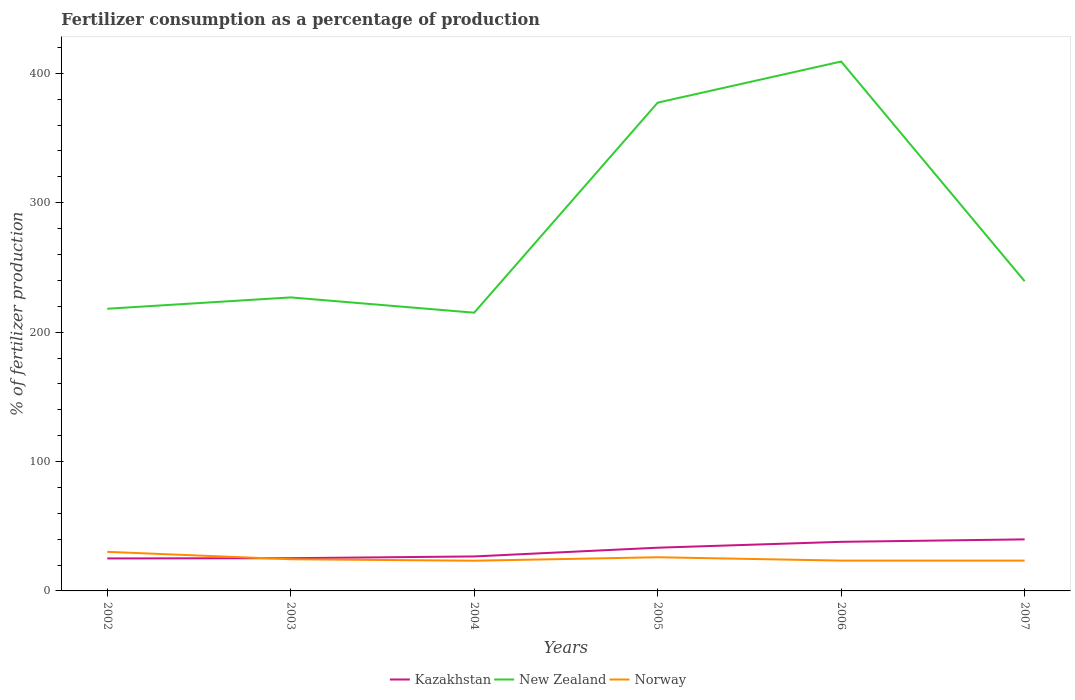Does the line corresponding to Norway intersect with the line corresponding to Kazakhstan?
Give a very brief answer. Yes. Is the number of lines equal to the number of legend labels?
Provide a short and direct response. Yes. Across all years, what is the maximum percentage of fertilizers consumed in New Zealand?
Make the answer very short. 215.02. What is the total percentage of fertilizers consumed in Norway in the graph?
Make the answer very short. 6.76. What is the difference between the highest and the second highest percentage of fertilizers consumed in Norway?
Give a very brief answer. 6.85. What is the difference between the highest and the lowest percentage of fertilizers consumed in New Zealand?
Ensure brevity in your answer.  2. How many lines are there?
Your answer should be very brief. 3. Are the values on the major ticks of Y-axis written in scientific E-notation?
Your answer should be compact. No. How are the legend labels stacked?
Your answer should be very brief. Horizontal. What is the title of the graph?
Give a very brief answer. Fertilizer consumption as a percentage of production. What is the label or title of the X-axis?
Provide a short and direct response. Years. What is the label or title of the Y-axis?
Keep it short and to the point. % of fertilizer production. What is the % of fertilizer production in Kazakhstan in 2002?
Offer a very short reply. 25.11. What is the % of fertilizer production of New Zealand in 2002?
Give a very brief answer. 218.08. What is the % of fertilizer production in Norway in 2002?
Keep it short and to the point. 30.19. What is the % of fertilizer production in Kazakhstan in 2003?
Your response must be concise. 25.3. What is the % of fertilizer production in New Zealand in 2003?
Provide a short and direct response. 226.83. What is the % of fertilizer production of Norway in 2003?
Make the answer very short. 24.48. What is the % of fertilizer production in Kazakhstan in 2004?
Your response must be concise. 26.65. What is the % of fertilizer production of New Zealand in 2004?
Offer a very short reply. 215.02. What is the % of fertilizer production in Norway in 2004?
Make the answer very short. 23.34. What is the % of fertilizer production of Kazakhstan in 2005?
Make the answer very short. 33.4. What is the % of fertilizer production in New Zealand in 2005?
Offer a terse response. 377.35. What is the % of fertilizer production in Norway in 2005?
Keep it short and to the point. 26.02. What is the % of fertilizer production in Kazakhstan in 2006?
Provide a short and direct response. 37.94. What is the % of fertilizer production in New Zealand in 2006?
Keep it short and to the point. 409.12. What is the % of fertilizer production in Norway in 2006?
Make the answer very short. 23.43. What is the % of fertilizer production in Kazakhstan in 2007?
Provide a succinct answer. 39.84. What is the % of fertilizer production of New Zealand in 2007?
Keep it short and to the point. 239.35. What is the % of fertilizer production of Norway in 2007?
Make the answer very short. 23.42. Across all years, what is the maximum % of fertilizer production in Kazakhstan?
Provide a short and direct response. 39.84. Across all years, what is the maximum % of fertilizer production of New Zealand?
Provide a short and direct response. 409.12. Across all years, what is the maximum % of fertilizer production in Norway?
Offer a very short reply. 30.19. Across all years, what is the minimum % of fertilizer production of Kazakhstan?
Make the answer very short. 25.11. Across all years, what is the minimum % of fertilizer production of New Zealand?
Provide a short and direct response. 215.02. Across all years, what is the minimum % of fertilizer production of Norway?
Offer a terse response. 23.34. What is the total % of fertilizer production of Kazakhstan in the graph?
Give a very brief answer. 188.23. What is the total % of fertilizer production in New Zealand in the graph?
Your answer should be very brief. 1685.75. What is the total % of fertilizer production of Norway in the graph?
Make the answer very short. 150.89. What is the difference between the % of fertilizer production of Kazakhstan in 2002 and that in 2003?
Your answer should be very brief. -0.19. What is the difference between the % of fertilizer production in New Zealand in 2002 and that in 2003?
Provide a succinct answer. -8.76. What is the difference between the % of fertilizer production of Norway in 2002 and that in 2003?
Offer a terse response. 5.71. What is the difference between the % of fertilizer production in Kazakhstan in 2002 and that in 2004?
Provide a succinct answer. -1.54. What is the difference between the % of fertilizer production in New Zealand in 2002 and that in 2004?
Ensure brevity in your answer.  3.05. What is the difference between the % of fertilizer production in Norway in 2002 and that in 2004?
Offer a very short reply. 6.85. What is the difference between the % of fertilizer production of Kazakhstan in 2002 and that in 2005?
Give a very brief answer. -8.3. What is the difference between the % of fertilizer production of New Zealand in 2002 and that in 2005?
Offer a terse response. -159.28. What is the difference between the % of fertilizer production of Norway in 2002 and that in 2005?
Offer a terse response. 4.18. What is the difference between the % of fertilizer production of Kazakhstan in 2002 and that in 2006?
Your answer should be compact. -12.83. What is the difference between the % of fertilizer production of New Zealand in 2002 and that in 2006?
Offer a terse response. -191.04. What is the difference between the % of fertilizer production in Norway in 2002 and that in 2006?
Ensure brevity in your answer.  6.76. What is the difference between the % of fertilizer production of Kazakhstan in 2002 and that in 2007?
Ensure brevity in your answer.  -14.73. What is the difference between the % of fertilizer production in New Zealand in 2002 and that in 2007?
Make the answer very short. -21.27. What is the difference between the % of fertilizer production of Norway in 2002 and that in 2007?
Your response must be concise. 6.77. What is the difference between the % of fertilizer production in Kazakhstan in 2003 and that in 2004?
Your response must be concise. -1.35. What is the difference between the % of fertilizer production in New Zealand in 2003 and that in 2004?
Your response must be concise. 11.81. What is the difference between the % of fertilizer production in Norway in 2003 and that in 2004?
Your answer should be very brief. 1.14. What is the difference between the % of fertilizer production of Kazakhstan in 2003 and that in 2005?
Offer a very short reply. -8.1. What is the difference between the % of fertilizer production of New Zealand in 2003 and that in 2005?
Provide a short and direct response. -150.52. What is the difference between the % of fertilizer production in Norway in 2003 and that in 2005?
Your answer should be compact. -1.53. What is the difference between the % of fertilizer production of Kazakhstan in 2003 and that in 2006?
Your answer should be compact. -12.64. What is the difference between the % of fertilizer production of New Zealand in 2003 and that in 2006?
Offer a very short reply. -182.28. What is the difference between the % of fertilizer production in Norway in 2003 and that in 2006?
Keep it short and to the point. 1.05. What is the difference between the % of fertilizer production of Kazakhstan in 2003 and that in 2007?
Offer a terse response. -14.54. What is the difference between the % of fertilizer production in New Zealand in 2003 and that in 2007?
Your response must be concise. -12.51. What is the difference between the % of fertilizer production of Norway in 2003 and that in 2007?
Ensure brevity in your answer.  1.06. What is the difference between the % of fertilizer production of Kazakhstan in 2004 and that in 2005?
Offer a terse response. -6.76. What is the difference between the % of fertilizer production of New Zealand in 2004 and that in 2005?
Your response must be concise. -162.33. What is the difference between the % of fertilizer production of Norway in 2004 and that in 2005?
Give a very brief answer. -2.67. What is the difference between the % of fertilizer production in Kazakhstan in 2004 and that in 2006?
Keep it short and to the point. -11.29. What is the difference between the % of fertilizer production of New Zealand in 2004 and that in 2006?
Provide a succinct answer. -194.1. What is the difference between the % of fertilizer production in Norway in 2004 and that in 2006?
Offer a very short reply. -0.09. What is the difference between the % of fertilizer production in Kazakhstan in 2004 and that in 2007?
Your answer should be very brief. -13.19. What is the difference between the % of fertilizer production of New Zealand in 2004 and that in 2007?
Provide a succinct answer. -24.33. What is the difference between the % of fertilizer production of Norway in 2004 and that in 2007?
Provide a short and direct response. -0.08. What is the difference between the % of fertilizer production in Kazakhstan in 2005 and that in 2006?
Offer a very short reply. -4.54. What is the difference between the % of fertilizer production of New Zealand in 2005 and that in 2006?
Your response must be concise. -31.76. What is the difference between the % of fertilizer production of Norway in 2005 and that in 2006?
Your response must be concise. 2.58. What is the difference between the % of fertilizer production of Kazakhstan in 2005 and that in 2007?
Provide a short and direct response. -6.44. What is the difference between the % of fertilizer production of New Zealand in 2005 and that in 2007?
Provide a succinct answer. 138.01. What is the difference between the % of fertilizer production of Norway in 2005 and that in 2007?
Offer a terse response. 2.6. What is the difference between the % of fertilizer production of Kazakhstan in 2006 and that in 2007?
Your answer should be very brief. -1.9. What is the difference between the % of fertilizer production in New Zealand in 2006 and that in 2007?
Provide a short and direct response. 169.77. What is the difference between the % of fertilizer production in Norway in 2006 and that in 2007?
Your answer should be very brief. 0.01. What is the difference between the % of fertilizer production in Kazakhstan in 2002 and the % of fertilizer production in New Zealand in 2003?
Give a very brief answer. -201.73. What is the difference between the % of fertilizer production in Kazakhstan in 2002 and the % of fertilizer production in Norway in 2003?
Your answer should be very brief. 0.62. What is the difference between the % of fertilizer production of New Zealand in 2002 and the % of fertilizer production of Norway in 2003?
Your answer should be very brief. 193.59. What is the difference between the % of fertilizer production of Kazakhstan in 2002 and the % of fertilizer production of New Zealand in 2004?
Provide a short and direct response. -189.91. What is the difference between the % of fertilizer production of Kazakhstan in 2002 and the % of fertilizer production of Norway in 2004?
Provide a short and direct response. 1.76. What is the difference between the % of fertilizer production in New Zealand in 2002 and the % of fertilizer production in Norway in 2004?
Give a very brief answer. 194.73. What is the difference between the % of fertilizer production of Kazakhstan in 2002 and the % of fertilizer production of New Zealand in 2005?
Your response must be concise. -352.25. What is the difference between the % of fertilizer production of Kazakhstan in 2002 and the % of fertilizer production of Norway in 2005?
Offer a very short reply. -0.91. What is the difference between the % of fertilizer production in New Zealand in 2002 and the % of fertilizer production in Norway in 2005?
Your answer should be compact. 192.06. What is the difference between the % of fertilizer production in Kazakhstan in 2002 and the % of fertilizer production in New Zealand in 2006?
Provide a short and direct response. -384.01. What is the difference between the % of fertilizer production in Kazakhstan in 2002 and the % of fertilizer production in Norway in 2006?
Keep it short and to the point. 1.67. What is the difference between the % of fertilizer production in New Zealand in 2002 and the % of fertilizer production in Norway in 2006?
Your answer should be compact. 194.64. What is the difference between the % of fertilizer production of Kazakhstan in 2002 and the % of fertilizer production of New Zealand in 2007?
Offer a very short reply. -214.24. What is the difference between the % of fertilizer production of Kazakhstan in 2002 and the % of fertilizer production of Norway in 2007?
Give a very brief answer. 1.69. What is the difference between the % of fertilizer production of New Zealand in 2002 and the % of fertilizer production of Norway in 2007?
Your answer should be very brief. 194.66. What is the difference between the % of fertilizer production in Kazakhstan in 2003 and the % of fertilizer production in New Zealand in 2004?
Offer a very short reply. -189.72. What is the difference between the % of fertilizer production of Kazakhstan in 2003 and the % of fertilizer production of Norway in 2004?
Make the answer very short. 1.95. What is the difference between the % of fertilizer production in New Zealand in 2003 and the % of fertilizer production in Norway in 2004?
Offer a very short reply. 203.49. What is the difference between the % of fertilizer production in Kazakhstan in 2003 and the % of fertilizer production in New Zealand in 2005?
Provide a succinct answer. -352.06. What is the difference between the % of fertilizer production in Kazakhstan in 2003 and the % of fertilizer production in Norway in 2005?
Offer a terse response. -0.72. What is the difference between the % of fertilizer production in New Zealand in 2003 and the % of fertilizer production in Norway in 2005?
Your answer should be compact. 200.82. What is the difference between the % of fertilizer production in Kazakhstan in 2003 and the % of fertilizer production in New Zealand in 2006?
Your response must be concise. -383.82. What is the difference between the % of fertilizer production of Kazakhstan in 2003 and the % of fertilizer production of Norway in 2006?
Your answer should be compact. 1.87. What is the difference between the % of fertilizer production of New Zealand in 2003 and the % of fertilizer production of Norway in 2006?
Provide a succinct answer. 203.4. What is the difference between the % of fertilizer production of Kazakhstan in 2003 and the % of fertilizer production of New Zealand in 2007?
Make the answer very short. -214.05. What is the difference between the % of fertilizer production of Kazakhstan in 2003 and the % of fertilizer production of Norway in 2007?
Ensure brevity in your answer.  1.88. What is the difference between the % of fertilizer production of New Zealand in 2003 and the % of fertilizer production of Norway in 2007?
Provide a succinct answer. 203.41. What is the difference between the % of fertilizer production of Kazakhstan in 2004 and the % of fertilizer production of New Zealand in 2005?
Your answer should be compact. -350.71. What is the difference between the % of fertilizer production in Kazakhstan in 2004 and the % of fertilizer production in Norway in 2005?
Ensure brevity in your answer.  0.63. What is the difference between the % of fertilizer production of New Zealand in 2004 and the % of fertilizer production of Norway in 2005?
Your answer should be very brief. 189. What is the difference between the % of fertilizer production in Kazakhstan in 2004 and the % of fertilizer production in New Zealand in 2006?
Ensure brevity in your answer.  -382.47. What is the difference between the % of fertilizer production in Kazakhstan in 2004 and the % of fertilizer production in Norway in 2006?
Your response must be concise. 3.21. What is the difference between the % of fertilizer production of New Zealand in 2004 and the % of fertilizer production of Norway in 2006?
Ensure brevity in your answer.  191.59. What is the difference between the % of fertilizer production in Kazakhstan in 2004 and the % of fertilizer production in New Zealand in 2007?
Ensure brevity in your answer.  -212.7. What is the difference between the % of fertilizer production in Kazakhstan in 2004 and the % of fertilizer production in Norway in 2007?
Keep it short and to the point. 3.23. What is the difference between the % of fertilizer production of New Zealand in 2004 and the % of fertilizer production of Norway in 2007?
Provide a succinct answer. 191.6. What is the difference between the % of fertilizer production of Kazakhstan in 2005 and the % of fertilizer production of New Zealand in 2006?
Your response must be concise. -375.72. What is the difference between the % of fertilizer production of Kazakhstan in 2005 and the % of fertilizer production of Norway in 2006?
Make the answer very short. 9.97. What is the difference between the % of fertilizer production of New Zealand in 2005 and the % of fertilizer production of Norway in 2006?
Keep it short and to the point. 353.92. What is the difference between the % of fertilizer production in Kazakhstan in 2005 and the % of fertilizer production in New Zealand in 2007?
Your answer should be compact. -205.95. What is the difference between the % of fertilizer production in Kazakhstan in 2005 and the % of fertilizer production in Norway in 2007?
Make the answer very short. 9.98. What is the difference between the % of fertilizer production of New Zealand in 2005 and the % of fertilizer production of Norway in 2007?
Offer a terse response. 353.93. What is the difference between the % of fertilizer production of Kazakhstan in 2006 and the % of fertilizer production of New Zealand in 2007?
Keep it short and to the point. -201.41. What is the difference between the % of fertilizer production in Kazakhstan in 2006 and the % of fertilizer production in Norway in 2007?
Provide a short and direct response. 14.52. What is the difference between the % of fertilizer production of New Zealand in 2006 and the % of fertilizer production of Norway in 2007?
Offer a terse response. 385.7. What is the average % of fertilizer production in Kazakhstan per year?
Give a very brief answer. 31.37. What is the average % of fertilizer production in New Zealand per year?
Provide a short and direct response. 280.96. What is the average % of fertilizer production of Norway per year?
Ensure brevity in your answer.  25.15. In the year 2002, what is the difference between the % of fertilizer production in Kazakhstan and % of fertilizer production in New Zealand?
Your answer should be compact. -192.97. In the year 2002, what is the difference between the % of fertilizer production of Kazakhstan and % of fertilizer production of Norway?
Your answer should be compact. -5.09. In the year 2002, what is the difference between the % of fertilizer production of New Zealand and % of fertilizer production of Norway?
Provide a succinct answer. 187.88. In the year 2003, what is the difference between the % of fertilizer production of Kazakhstan and % of fertilizer production of New Zealand?
Provide a short and direct response. -201.54. In the year 2003, what is the difference between the % of fertilizer production of Kazakhstan and % of fertilizer production of Norway?
Provide a succinct answer. 0.81. In the year 2003, what is the difference between the % of fertilizer production of New Zealand and % of fertilizer production of Norway?
Keep it short and to the point. 202.35. In the year 2004, what is the difference between the % of fertilizer production in Kazakhstan and % of fertilizer production in New Zealand?
Make the answer very short. -188.38. In the year 2004, what is the difference between the % of fertilizer production in Kazakhstan and % of fertilizer production in Norway?
Ensure brevity in your answer.  3.3. In the year 2004, what is the difference between the % of fertilizer production of New Zealand and % of fertilizer production of Norway?
Offer a terse response. 191.68. In the year 2005, what is the difference between the % of fertilizer production of Kazakhstan and % of fertilizer production of New Zealand?
Make the answer very short. -343.95. In the year 2005, what is the difference between the % of fertilizer production of Kazakhstan and % of fertilizer production of Norway?
Your response must be concise. 7.38. In the year 2005, what is the difference between the % of fertilizer production in New Zealand and % of fertilizer production in Norway?
Offer a very short reply. 351.34. In the year 2006, what is the difference between the % of fertilizer production of Kazakhstan and % of fertilizer production of New Zealand?
Provide a short and direct response. -371.18. In the year 2006, what is the difference between the % of fertilizer production in Kazakhstan and % of fertilizer production in Norway?
Keep it short and to the point. 14.5. In the year 2006, what is the difference between the % of fertilizer production in New Zealand and % of fertilizer production in Norway?
Your answer should be compact. 385.68. In the year 2007, what is the difference between the % of fertilizer production in Kazakhstan and % of fertilizer production in New Zealand?
Keep it short and to the point. -199.51. In the year 2007, what is the difference between the % of fertilizer production in Kazakhstan and % of fertilizer production in Norway?
Keep it short and to the point. 16.42. In the year 2007, what is the difference between the % of fertilizer production in New Zealand and % of fertilizer production in Norway?
Ensure brevity in your answer.  215.93. What is the ratio of the % of fertilizer production of New Zealand in 2002 to that in 2003?
Your response must be concise. 0.96. What is the ratio of the % of fertilizer production in Norway in 2002 to that in 2003?
Offer a very short reply. 1.23. What is the ratio of the % of fertilizer production in Kazakhstan in 2002 to that in 2004?
Provide a succinct answer. 0.94. What is the ratio of the % of fertilizer production of New Zealand in 2002 to that in 2004?
Give a very brief answer. 1.01. What is the ratio of the % of fertilizer production in Norway in 2002 to that in 2004?
Provide a succinct answer. 1.29. What is the ratio of the % of fertilizer production in Kazakhstan in 2002 to that in 2005?
Your answer should be compact. 0.75. What is the ratio of the % of fertilizer production of New Zealand in 2002 to that in 2005?
Give a very brief answer. 0.58. What is the ratio of the % of fertilizer production in Norway in 2002 to that in 2005?
Provide a short and direct response. 1.16. What is the ratio of the % of fertilizer production of Kazakhstan in 2002 to that in 2006?
Your answer should be compact. 0.66. What is the ratio of the % of fertilizer production in New Zealand in 2002 to that in 2006?
Provide a short and direct response. 0.53. What is the ratio of the % of fertilizer production in Norway in 2002 to that in 2006?
Offer a terse response. 1.29. What is the ratio of the % of fertilizer production of Kazakhstan in 2002 to that in 2007?
Offer a very short reply. 0.63. What is the ratio of the % of fertilizer production in New Zealand in 2002 to that in 2007?
Make the answer very short. 0.91. What is the ratio of the % of fertilizer production in Norway in 2002 to that in 2007?
Offer a terse response. 1.29. What is the ratio of the % of fertilizer production in Kazakhstan in 2003 to that in 2004?
Your answer should be very brief. 0.95. What is the ratio of the % of fertilizer production in New Zealand in 2003 to that in 2004?
Provide a succinct answer. 1.05. What is the ratio of the % of fertilizer production of Norway in 2003 to that in 2004?
Give a very brief answer. 1.05. What is the ratio of the % of fertilizer production of Kazakhstan in 2003 to that in 2005?
Provide a short and direct response. 0.76. What is the ratio of the % of fertilizer production of New Zealand in 2003 to that in 2005?
Ensure brevity in your answer.  0.6. What is the ratio of the % of fertilizer production of Norway in 2003 to that in 2005?
Offer a terse response. 0.94. What is the ratio of the % of fertilizer production of Kazakhstan in 2003 to that in 2006?
Offer a very short reply. 0.67. What is the ratio of the % of fertilizer production of New Zealand in 2003 to that in 2006?
Provide a succinct answer. 0.55. What is the ratio of the % of fertilizer production of Norway in 2003 to that in 2006?
Ensure brevity in your answer.  1.04. What is the ratio of the % of fertilizer production in Kazakhstan in 2003 to that in 2007?
Give a very brief answer. 0.64. What is the ratio of the % of fertilizer production of New Zealand in 2003 to that in 2007?
Keep it short and to the point. 0.95. What is the ratio of the % of fertilizer production in Norway in 2003 to that in 2007?
Keep it short and to the point. 1.05. What is the ratio of the % of fertilizer production in Kazakhstan in 2004 to that in 2005?
Make the answer very short. 0.8. What is the ratio of the % of fertilizer production in New Zealand in 2004 to that in 2005?
Offer a very short reply. 0.57. What is the ratio of the % of fertilizer production of Norway in 2004 to that in 2005?
Ensure brevity in your answer.  0.9. What is the ratio of the % of fertilizer production of Kazakhstan in 2004 to that in 2006?
Give a very brief answer. 0.7. What is the ratio of the % of fertilizer production in New Zealand in 2004 to that in 2006?
Offer a very short reply. 0.53. What is the ratio of the % of fertilizer production in Norway in 2004 to that in 2006?
Offer a very short reply. 1. What is the ratio of the % of fertilizer production in Kazakhstan in 2004 to that in 2007?
Your answer should be very brief. 0.67. What is the ratio of the % of fertilizer production in New Zealand in 2004 to that in 2007?
Offer a very short reply. 0.9. What is the ratio of the % of fertilizer production of Norway in 2004 to that in 2007?
Provide a short and direct response. 1. What is the ratio of the % of fertilizer production in Kazakhstan in 2005 to that in 2006?
Make the answer very short. 0.88. What is the ratio of the % of fertilizer production of New Zealand in 2005 to that in 2006?
Ensure brevity in your answer.  0.92. What is the ratio of the % of fertilizer production in Norway in 2005 to that in 2006?
Keep it short and to the point. 1.11. What is the ratio of the % of fertilizer production of Kazakhstan in 2005 to that in 2007?
Provide a short and direct response. 0.84. What is the ratio of the % of fertilizer production of New Zealand in 2005 to that in 2007?
Give a very brief answer. 1.58. What is the ratio of the % of fertilizer production in Norway in 2005 to that in 2007?
Ensure brevity in your answer.  1.11. What is the ratio of the % of fertilizer production of Kazakhstan in 2006 to that in 2007?
Keep it short and to the point. 0.95. What is the ratio of the % of fertilizer production in New Zealand in 2006 to that in 2007?
Provide a short and direct response. 1.71. What is the ratio of the % of fertilizer production in Norway in 2006 to that in 2007?
Ensure brevity in your answer.  1. What is the difference between the highest and the second highest % of fertilizer production in Kazakhstan?
Give a very brief answer. 1.9. What is the difference between the highest and the second highest % of fertilizer production of New Zealand?
Your answer should be very brief. 31.76. What is the difference between the highest and the second highest % of fertilizer production in Norway?
Make the answer very short. 4.18. What is the difference between the highest and the lowest % of fertilizer production of Kazakhstan?
Provide a short and direct response. 14.73. What is the difference between the highest and the lowest % of fertilizer production in New Zealand?
Give a very brief answer. 194.1. What is the difference between the highest and the lowest % of fertilizer production of Norway?
Offer a very short reply. 6.85. 